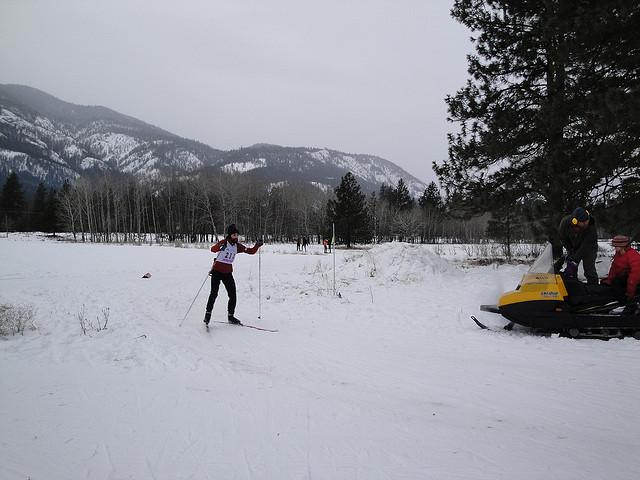What is the name of the yellow vehicle the man in red is on? snow mobile 